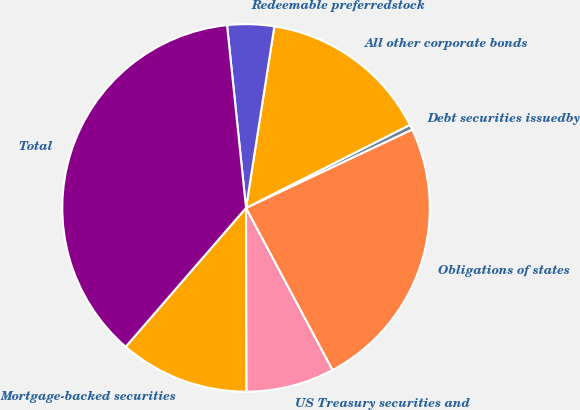Convert chart to OTSL. <chart><loc_0><loc_0><loc_500><loc_500><pie_chart><fcel>Mortgage-backed securities<fcel>US Treasury securities and<fcel>Obligations of states<fcel>Debt securities issuedby<fcel>All other corporate bonds<fcel>Redeemable preferredstock<fcel>Total<nl><fcel>11.41%<fcel>7.76%<fcel>24.21%<fcel>0.45%<fcel>15.07%<fcel>4.11%<fcel>36.99%<nl></chart> 